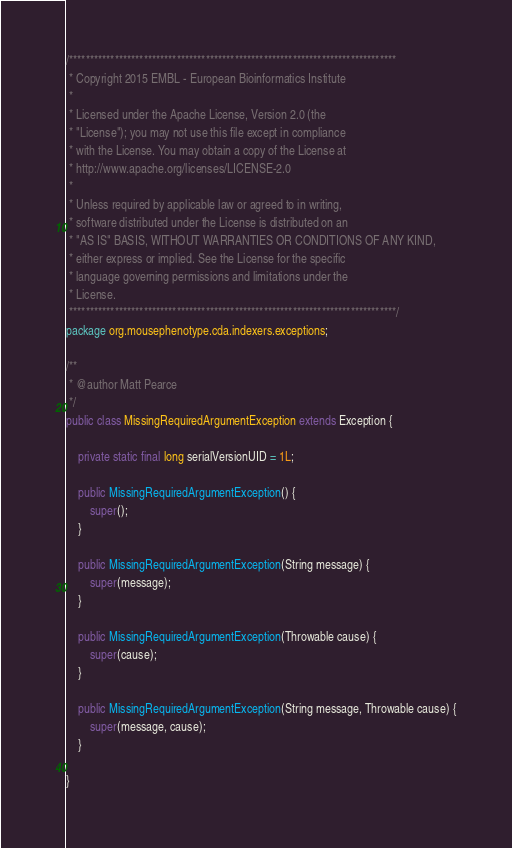<code> <loc_0><loc_0><loc_500><loc_500><_Java_>/*******************************************************************************
 * Copyright 2015 EMBL - European Bioinformatics Institute
 *
 * Licensed under the Apache License, Version 2.0 (the
 * "License"); you may not use this file except in compliance
 * with the License. You may obtain a copy of the License at
 * http://www.apache.org/licenses/LICENSE-2.0
 *
 * Unless required by applicable law or agreed to in writing,
 * software distributed under the License is distributed on an
 * "AS IS" BASIS, WITHOUT WARRANTIES OR CONDITIONS OF ANY KIND,
 * either express or implied. See the License for the specific
 * language governing permissions and limitations under the
 * License.
 *******************************************************************************/
package org.mousephenotype.cda.indexers.exceptions;

/**
 * @author Matt Pearce
 */
public class MissingRequiredArgumentException extends Exception {

	private static final long serialVersionUID = 1L;

	public MissingRequiredArgumentException() {
		super();
	}

	public MissingRequiredArgumentException(String message) {
		super(message);
	}

	public MissingRequiredArgumentException(Throwable cause) {
		super(cause);
	}

	public MissingRequiredArgumentException(String message, Throwable cause) {
		super(message, cause);
	}

}
</code> 